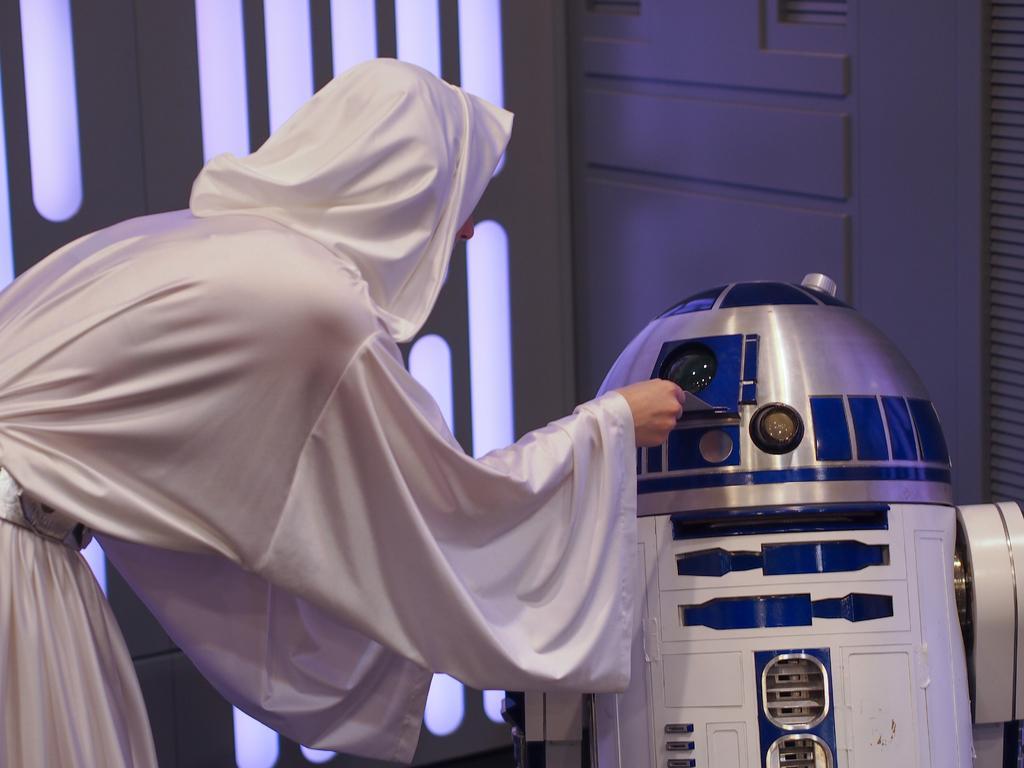Please provide a concise description of this image. In this image there is a person standing and placing something into a machine, which is in front of him. In the background there is a wall. 